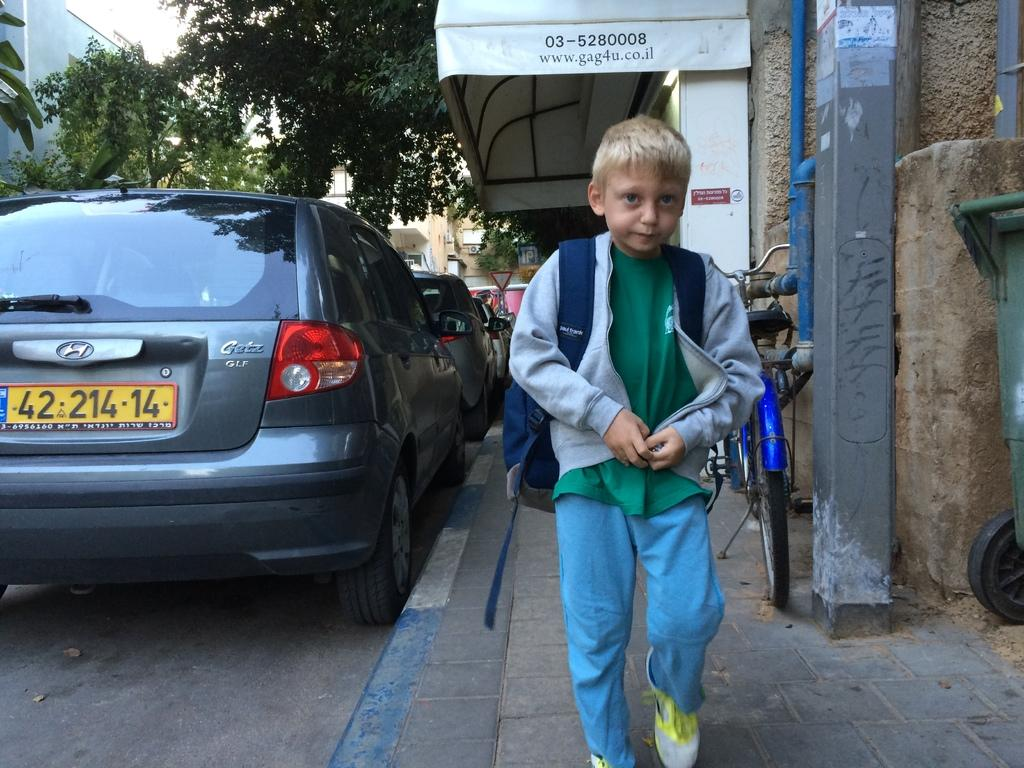What is the main subject of the image? The main subject of the image is a kid. What is the kid doing in the image? The kid is walking on a footpath. What can be seen beside the footpath? There are cars parked beside the footpath. What is on the right side of the image? There is a bicycle on the right side of the image. What is visible in the background of the image? There are trees and houses in the background of the image. What type of arch can be seen in the background? There is no arch present in the background; it features a kid walking on a footpath with parked cars, a bicycle, trees, and houses. What kind of map is the kid holding in the image? There is no map visible in the image; the kid is simply walking on a footpath. 